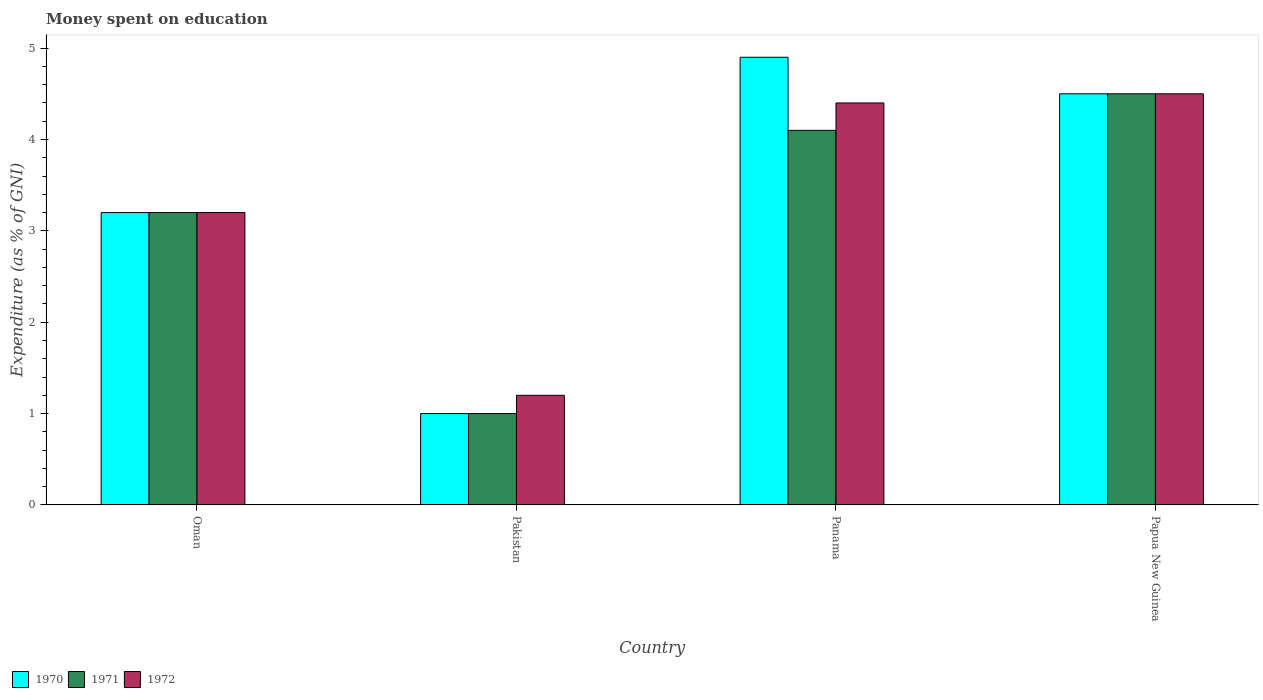How many groups of bars are there?
Ensure brevity in your answer.  4. How many bars are there on the 4th tick from the left?
Make the answer very short. 3. How many bars are there on the 3rd tick from the right?
Give a very brief answer. 3. What is the label of the 1st group of bars from the left?
Keep it short and to the point. Oman. Across all countries, what is the maximum amount of money spent on education in 1970?
Your answer should be very brief. 4.9. Across all countries, what is the minimum amount of money spent on education in 1970?
Your response must be concise. 1. In which country was the amount of money spent on education in 1972 maximum?
Keep it short and to the point. Papua New Guinea. What is the total amount of money spent on education in 1972 in the graph?
Make the answer very short. 13.3. What is the difference between the amount of money spent on education in 1970 in Oman and that in Panama?
Provide a succinct answer. -1.7. What is the difference between the amount of money spent on education of/in 1970 and amount of money spent on education of/in 1971 in Panama?
Offer a very short reply. 0.8. In how many countries, is the amount of money spent on education in 1971 greater than 3.8 %?
Offer a very short reply. 2. What is the ratio of the amount of money spent on education in 1970 in Oman to that in Papua New Guinea?
Your answer should be very brief. 0.71. Is the amount of money spent on education in 1971 in Oman less than that in Panama?
Offer a terse response. Yes. What is the difference between the highest and the second highest amount of money spent on education in 1970?
Provide a short and direct response. -1.7. In how many countries, is the amount of money spent on education in 1970 greater than the average amount of money spent on education in 1970 taken over all countries?
Offer a very short reply. 2. Is the sum of the amount of money spent on education in 1971 in Oman and Pakistan greater than the maximum amount of money spent on education in 1970 across all countries?
Offer a very short reply. No. What does the 1st bar from the left in Oman represents?
Your answer should be compact. 1970. Is it the case that in every country, the sum of the amount of money spent on education in 1971 and amount of money spent on education in 1970 is greater than the amount of money spent on education in 1972?
Your response must be concise. Yes. How many bars are there?
Provide a succinct answer. 12. What is the difference between two consecutive major ticks on the Y-axis?
Offer a terse response. 1. Does the graph contain any zero values?
Provide a short and direct response. No. Where does the legend appear in the graph?
Offer a very short reply. Bottom left. What is the title of the graph?
Make the answer very short. Money spent on education. Does "1967" appear as one of the legend labels in the graph?
Ensure brevity in your answer.  No. What is the label or title of the X-axis?
Offer a terse response. Country. What is the label or title of the Y-axis?
Provide a short and direct response. Expenditure (as % of GNI). What is the Expenditure (as % of GNI) of 1972 in Pakistan?
Your answer should be compact. 1.2. What is the Expenditure (as % of GNI) of 1972 in Papua New Guinea?
Make the answer very short. 4.5. Across all countries, what is the maximum Expenditure (as % of GNI) in 1970?
Provide a short and direct response. 4.9. Across all countries, what is the minimum Expenditure (as % of GNI) in 1971?
Your answer should be very brief. 1. Across all countries, what is the minimum Expenditure (as % of GNI) of 1972?
Offer a very short reply. 1.2. What is the total Expenditure (as % of GNI) of 1971 in the graph?
Ensure brevity in your answer.  12.8. What is the difference between the Expenditure (as % of GNI) in 1971 in Oman and that in Pakistan?
Offer a terse response. 2.2. What is the difference between the Expenditure (as % of GNI) in 1972 in Oman and that in Panama?
Offer a terse response. -1.2. What is the difference between the Expenditure (as % of GNI) in 1971 in Oman and that in Papua New Guinea?
Your answer should be very brief. -1.3. What is the difference between the Expenditure (as % of GNI) in 1972 in Oman and that in Papua New Guinea?
Offer a very short reply. -1.3. What is the difference between the Expenditure (as % of GNI) in 1971 in Oman and the Expenditure (as % of GNI) in 1972 in Pakistan?
Your answer should be compact. 2. What is the difference between the Expenditure (as % of GNI) in 1970 in Oman and the Expenditure (as % of GNI) in 1971 in Papua New Guinea?
Make the answer very short. -1.3. What is the difference between the Expenditure (as % of GNI) in 1970 in Pakistan and the Expenditure (as % of GNI) in 1972 in Panama?
Your answer should be very brief. -3.4. What is the difference between the Expenditure (as % of GNI) of 1971 in Pakistan and the Expenditure (as % of GNI) of 1972 in Panama?
Provide a succinct answer. -3.4. What is the difference between the Expenditure (as % of GNI) of 1970 in Pakistan and the Expenditure (as % of GNI) of 1971 in Papua New Guinea?
Provide a succinct answer. -3.5. What is the difference between the Expenditure (as % of GNI) of 1970 in Pakistan and the Expenditure (as % of GNI) of 1972 in Papua New Guinea?
Your answer should be very brief. -3.5. What is the difference between the Expenditure (as % of GNI) in 1971 in Pakistan and the Expenditure (as % of GNI) in 1972 in Papua New Guinea?
Provide a short and direct response. -3.5. What is the difference between the Expenditure (as % of GNI) in 1970 in Panama and the Expenditure (as % of GNI) in 1971 in Papua New Guinea?
Offer a terse response. 0.4. What is the difference between the Expenditure (as % of GNI) of 1970 in Panama and the Expenditure (as % of GNI) of 1972 in Papua New Guinea?
Your answer should be very brief. 0.4. What is the average Expenditure (as % of GNI) in 1971 per country?
Give a very brief answer. 3.2. What is the average Expenditure (as % of GNI) in 1972 per country?
Provide a short and direct response. 3.33. What is the difference between the Expenditure (as % of GNI) in 1971 and Expenditure (as % of GNI) in 1972 in Oman?
Keep it short and to the point. 0. What is the difference between the Expenditure (as % of GNI) of 1970 and Expenditure (as % of GNI) of 1971 in Pakistan?
Offer a terse response. 0. What is the difference between the Expenditure (as % of GNI) in 1970 and Expenditure (as % of GNI) in 1972 in Pakistan?
Your response must be concise. -0.2. What is the difference between the Expenditure (as % of GNI) of 1970 and Expenditure (as % of GNI) of 1971 in Panama?
Offer a very short reply. 0.8. What is the difference between the Expenditure (as % of GNI) of 1970 and Expenditure (as % of GNI) of 1972 in Panama?
Provide a short and direct response. 0.5. What is the difference between the Expenditure (as % of GNI) of 1971 and Expenditure (as % of GNI) of 1972 in Panama?
Provide a short and direct response. -0.3. What is the difference between the Expenditure (as % of GNI) of 1970 and Expenditure (as % of GNI) of 1972 in Papua New Guinea?
Provide a succinct answer. 0. What is the ratio of the Expenditure (as % of GNI) in 1970 in Oman to that in Pakistan?
Provide a succinct answer. 3.2. What is the ratio of the Expenditure (as % of GNI) in 1971 in Oman to that in Pakistan?
Your response must be concise. 3.2. What is the ratio of the Expenditure (as % of GNI) in 1972 in Oman to that in Pakistan?
Make the answer very short. 2.67. What is the ratio of the Expenditure (as % of GNI) in 1970 in Oman to that in Panama?
Keep it short and to the point. 0.65. What is the ratio of the Expenditure (as % of GNI) of 1971 in Oman to that in Panama?
Your answer should be very brief. 0.78. What is the ratio of the Expenditure (as % of GNI) of 1972 in Oman to that in Panama?
Give a very brief answer. 0.73. What is the ratio of the Expenditure (as % of GNI) in 1970 in Oman to that in Papua New Guinea?
Your answer should be compact. 0.71. What is the ratio of the Expenditure (as % of GNI) of 1971 in Oman to that in Papua New Guinea?
Offer a terse response. 0.71. What is the ratio of the Expenditure (as % of GNI) in 1972 in Oman to that in Papua New Guinea?
Your response must be concise. 0.71. What is the ratio of the Expenditure (as % of GNI) of 1970 in Pakistan to that in Panama?
Your answer should be compact. 0.2. What is the ratio of the Expenditure (as % of GNI) of 1971 in Pakistan to that in Panama?
Make the answer very short. 0.24. What is the ratio of the Expenditure (as % of GNI) in 1972 in Pakistan to that in Panama?
Your response must be concise. 0.27. What is the ratio of the Expenditure (as % of GNI) of 1970 in Pakistan to that in Papua New Guinea?
Offer a very short reply. 0.22. What is the ratio of the Expenditure (as % of GNI) in 1971 in Pakistan to that in Papua New Guinea?
Your answer should be very brief. 0.22. What is the ratio of the Expenditure (as % of GNI) in 1972 in Pakistan to that in Papua New Guinea?
Provide a short and direct response. 0.27. What is the ratio of the Expenditure (as % of GNI) of 1970 in Panama to that in Papua New Guinea?
Offer a very short reply. 1.09. What is the ratio of the Expenditure (as % of GNI) of 1971 in Panama to that in Papua New Guinea?
Ensure brevity in your answer.  0.91. What is the ratio of the Expenditure (as % of GNI) of 1972 in Panama to that in Papua New Guinea?
Keep it short and to the point. 0.98. What is the difference between the highest and the second highest Expenditure (as % of GNI) of 1972?
Make the answer very short. 0.1. What is the difference between the highest and the lowest Expenditure (as % of GNI) in 1972?
Give a very brief answer. 3.3. 